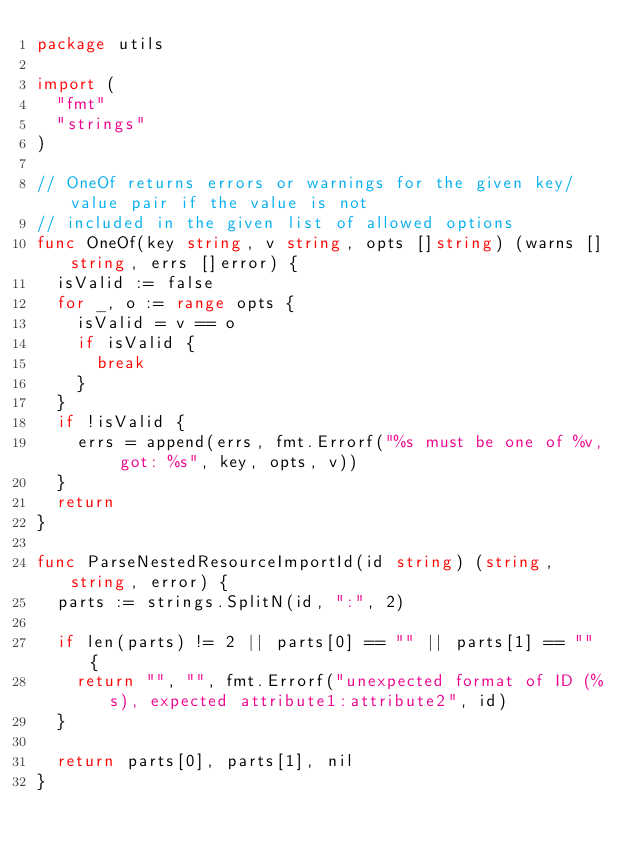Convert code to text. <code><loc_0><loc_0><loc_500><loc_500><_Go_>package utils

import (
	"fmt"
	"strings"
)

// OneOf returns errors or warnings for the given key/value pair if the value is not
// included in the given list of allowed options
func OneOf(key string, v string, opts []string) (warns []string, errs []error) {
	isValid := false
	for _, o := range opts {
		isValid = v == o
		if isValid {
			break
		}
	}
	if !isValid {
		errs = append(errs, fmt.Errorf("%s must be one of %v, got: %s", key, opts, v))
	}
	return
}

func ParseNestedResourceImportId(id string) (string, string, error) {
	parts := strings.SplitN(id, ":", 2)

	if len(parts) != 2 || parts[0] == "" || parts[1] == "" {
		return "", "", fmt.Errorf("unexpected format of ID (%s), expected attribute1:attribute2", id)
	}

	return parts[0], parts[1], nil
}
</code> 